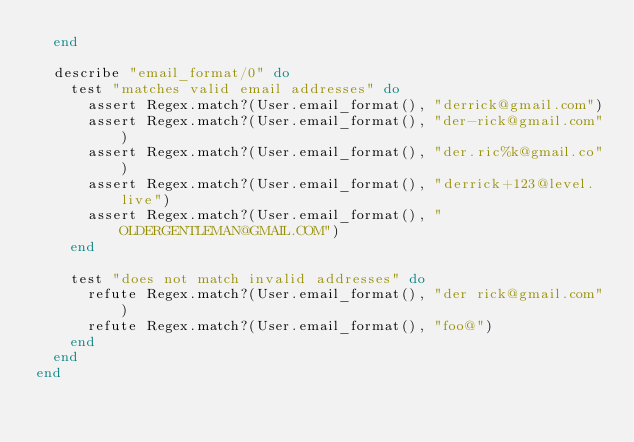Convert code to text. <code><loc_0><loc_0><loc_500><loc_500><_Elixir_>  end

  describe "email_format/0" do
    test "matches valid email addresses" do
      assert Regex.match?(User.email_format(), "derrick@gmail.com")
      assert Regex.match?(User.email_format(), "der-rick@gmail.com")
      assert Regex.match?(User.email_format(), "der.ric%k@gmail.co")
      assert Regex.match?(User.email_format(), "derrick+123@level.live")
      assert Regex.match?(User.email_format(), "OLDERGENTLEMAN@GMAIL.COM")
    end

    test "does not match invalid addresses" do
      refute Regex.match?(User.email_format(), "der rick@gmail.com")
      refute Regex.match?(User.email_format(), "foo@")
    end
  end
end
</code> 